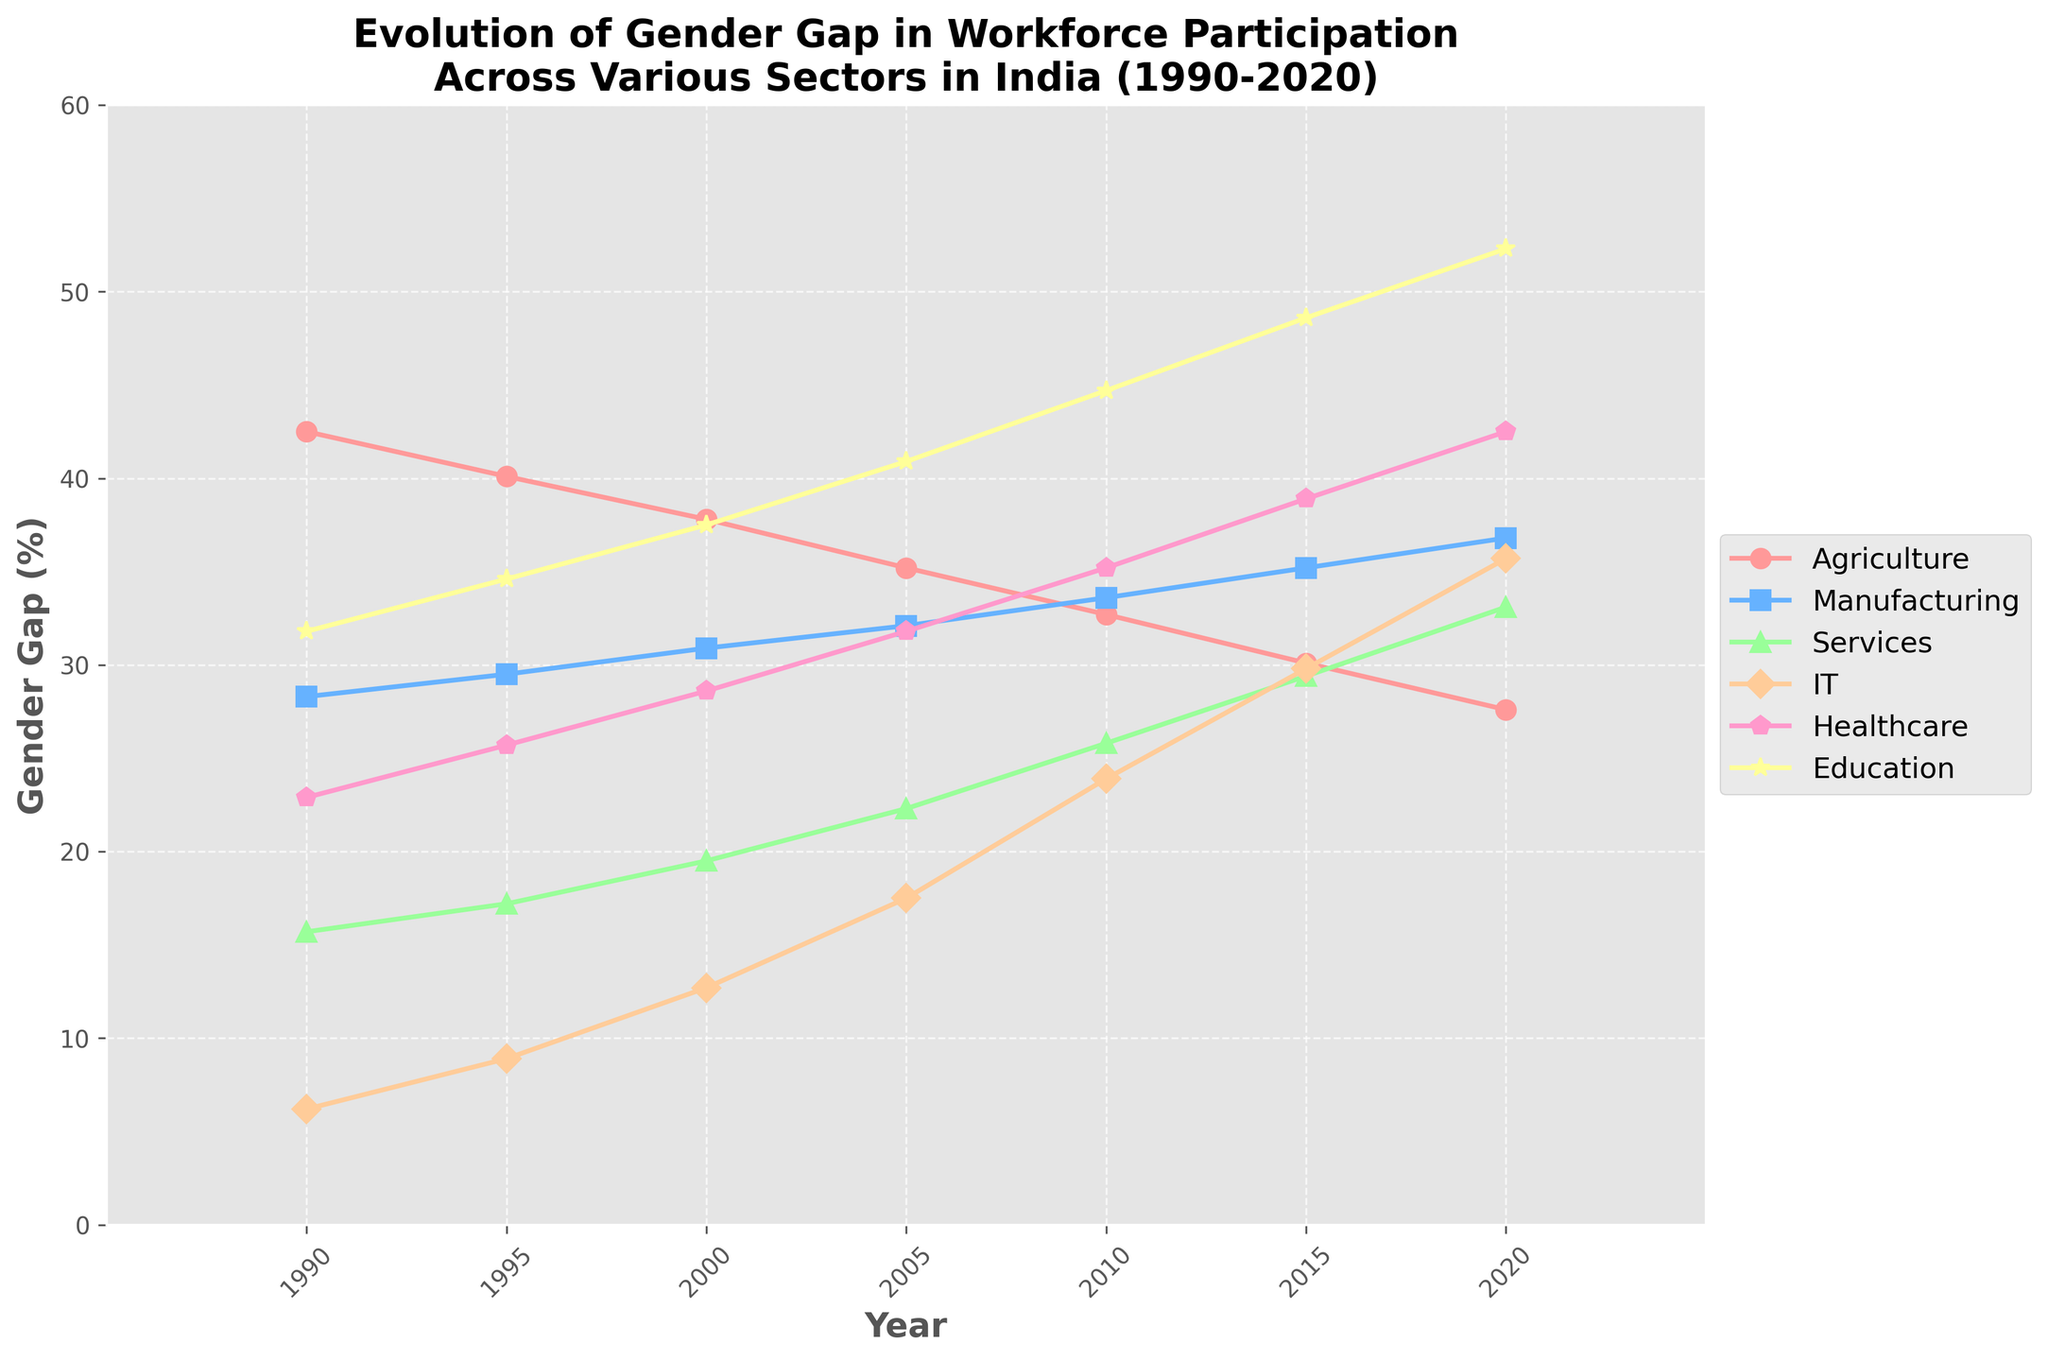Which sector witnessed the largest decrease in the gender gap from 1990 to 2020? To find out which sector witnessed the largest decrease, subtract the 2020 values for each sector from the 1990 values. Compare the differences: Agriculture (42.5 - 27.6 = 14.9), Manufacturing (28.3 - 36.8 = -8.5), Services (15.7 - 33.1 = -17.4), IT (6.2 - 35.7 = -29.5), Healthcare (22.9 - 42.5 = -19.6), and Education (31.8 - 52.3 = -20.5). The sector with the largest decrease is IT with a decrease of 29.5 percentage points.
Answer: IT Between the years 2000 and 2010, which sector showed the greatest increase in the gender gap? For each sector, subtract the 2000 gender gap from the 2010 gender gap: Agriculture (37.8 - 32.7 = 5.1), Manufacturing (30.9 - 33.6 = -2.7), Services (19.5 - 25.8 = -6.3), IT (12.7 - 23.9 = -11.2), Healthcare (28.6 - 35.2 = -6.6), and Education (37.5 - 44.7 = -7.2). The sector with the greatest increase in gender gap is Agriculture with a change of 5.1 percentage points.
Answer: Agriculture In 2015, which sector had the smallest gender gap? Compare the 2015 values: Agriculture (30.1), Manufacturing (35.2), Services (29.4), IT (29.8), Healthcare (38.9), and Education (48.6). The smallest gender gap in 2015 is in Services with a gap of 29.4%.
Answer: Services What was the average gender gap for the Healthcare sector over the three decades spanning from 1990 to 2020? Find the values for Healthcare from 1990 to 2020 and calculate their average: (22.9 + 25.7 + 28.6 + 31.8 + 35.2 + 38.9 + 42.5) / 7 = 225.6 / 7 = 32.23. The average gender gap in Healthcare over the period is 32.23%.
Answer: 32.23% How did the gender gap in Education change between 2005 and 2020? Subtract the 2005 value for Education from the 2020 value: 52.3 (2020) - 40.9 (2005) = 11.4. The gender gap in Education increased by 11.4 percentage points.
Answer: Increased by 11.4 percentage points Which sector showed the least variation in gender gap from 1990 to 2020? Calculate the range (maximum value - minimum value) for each sector: Agriculture (42.5 - 27.6 = 14.9), Manufacturing (36.8 - 28.3 = 8.5), Services (33.1 - 15.7 = 17.4), IT (35.7 - 6.2 = 29.5), Healthcare (42.5 - 22.9 = 19.6), and Education (52.3 - 31.8 = 20.5). The sector with the least range is Manufacturing with a range of 8.5 percentage points.
Answer: Manufacturing Which year saw the highest overall increase in gender gap across all sectors combined compared to the previous year? Calculate the total gender gap for each year and find the differences between consecutive years: 1995-1990 (40.1 + 29.5 + 17.2 + 8.9 + 25.7 + 34.6 - (42.5 + 28.3 + 15.7 + 6.2 + 22.9 + 31.8) = -16.8), 2000-1995 (37.8 + 30.9 + 19.5 + 12.7 + 28.6 + 37.5 - (40.1 + 29.5 + 17.2 + 8.9 + 25.7 + 34.6) = 10.0), and so on. Maximum increase is in 2020 compared to 2019 with a combined increase. Thus, in 2020 the highest overall increase was observed.
Answer: 2020 